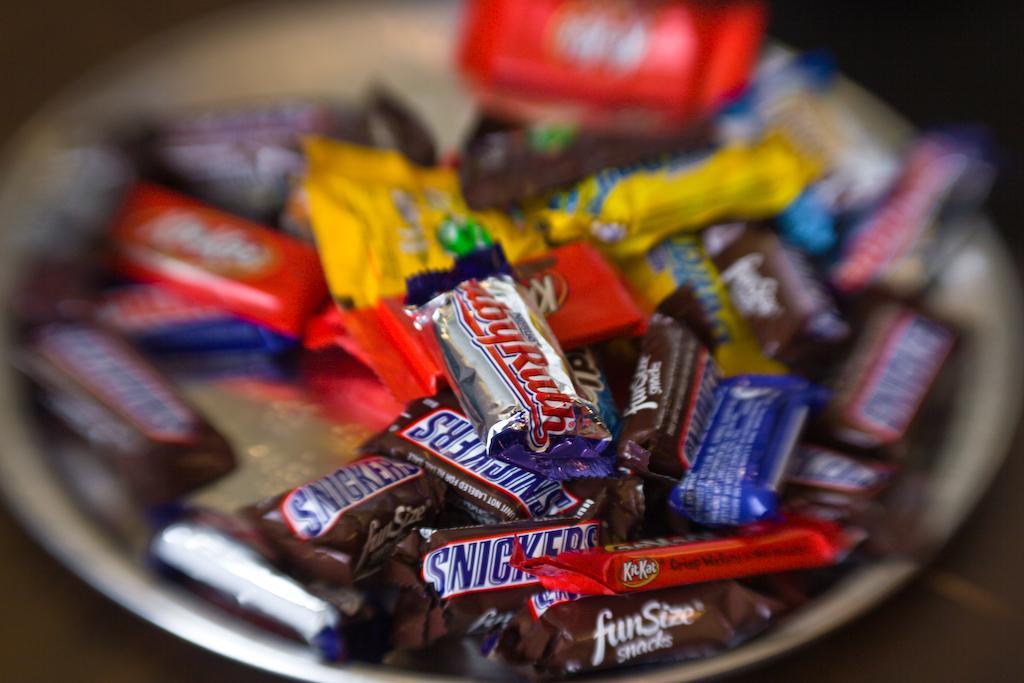Can you describe this image briefly? In the image there are a lot of chocolates kept in a plate and some of the chocolates were blurred in the picture. 